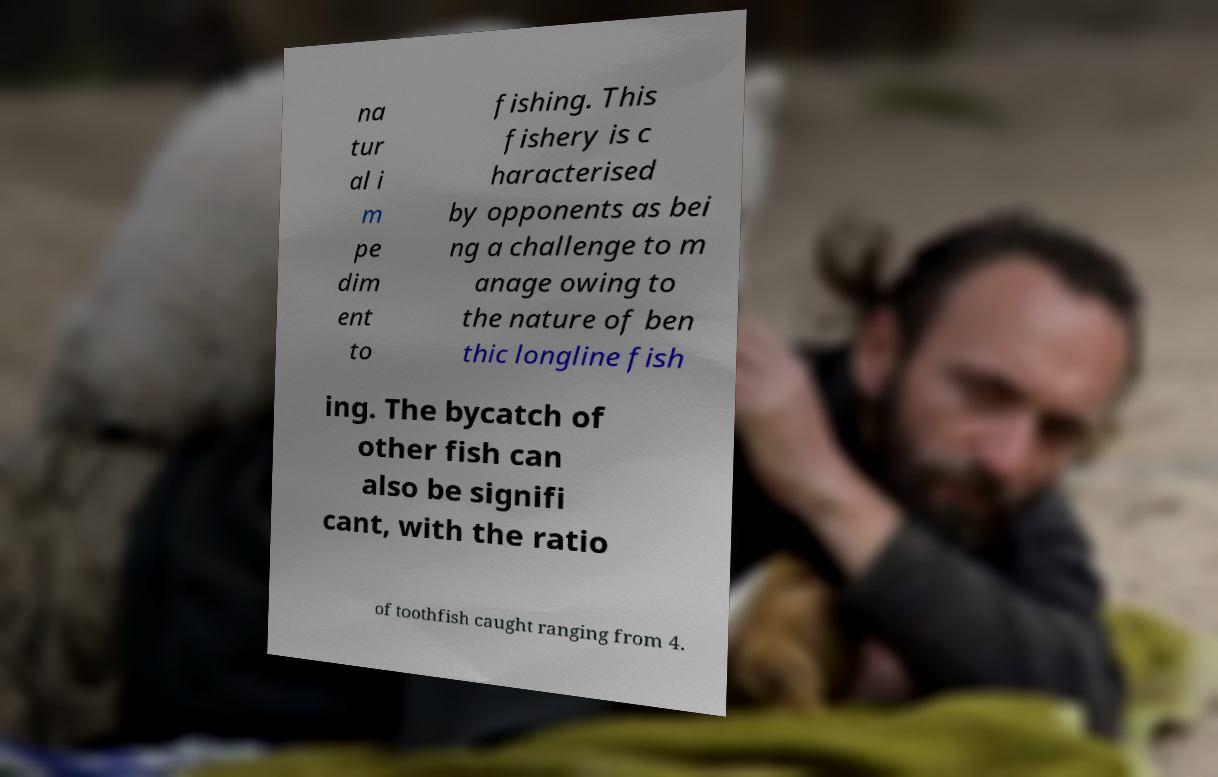There's text embedded in this image that I need extracted. Can you transcribe it verbatim? na tur al i m pe dim ent to fishing. This fishery is c haracterised by opponents as bei ng a challenge to m anage owing to the nature of ben thic longline fish ing. The bycatch of other fish can also be signifi cant, with the ratio of toothfish caught ranging from 4. 